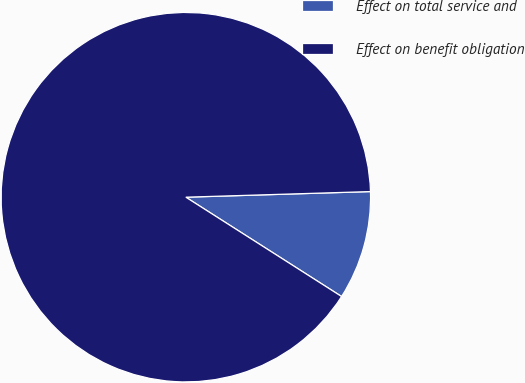Convert chart. <chart><loc_0><loc_0><loc_500><loc_500><pie_chart><fcel>Effect on total service and<fcel>Effect on benefit obligation<nl><fcel>9.52%<fcel>90.48%<nl></chart> 